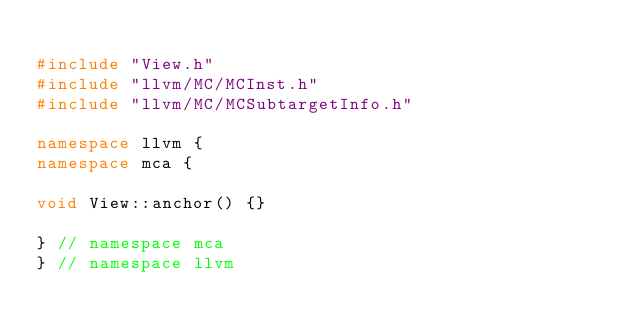Convert code to text. <code><loc_0><loc_0><loc_500><loc_500><_C++_>
#include "View.h"
#include "llvm/MC/MCInst.h"
#include "llvm/MC/MCSubtargetInfo.h"

namespace llvm {
namespace mca {

void View::anchor() {}

} // namespace mca
} // namespace llvm
</code> 